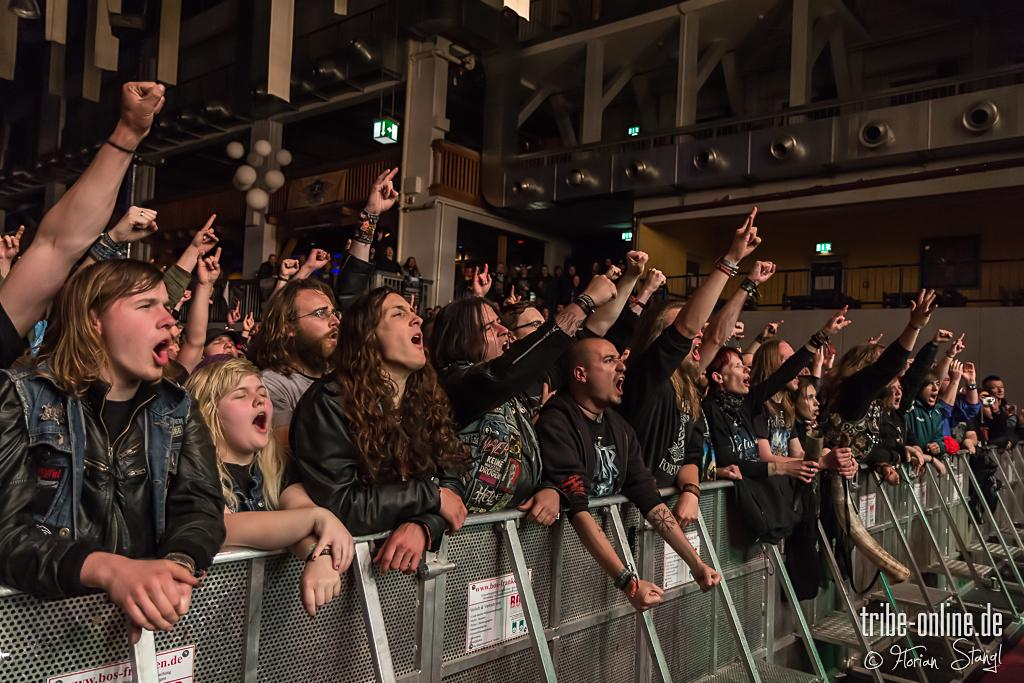How many people can be seen in the image? There are people in the image, but the exact number is not specified. What is located at the bottom of the image? There is a fence at the bottom of some sort at the bottom of the image. What can be seen in the background of the image? There is a building in the background of the image. What type of structure is present in the image? Railings are present in the image. What can be seen illuminated in the image? There are lights visible in the image. What type of tub is visible in the image? There is no tub present in the image. What religious symbols can be seen in the image? There is no mention of any religious symbols in the image. 